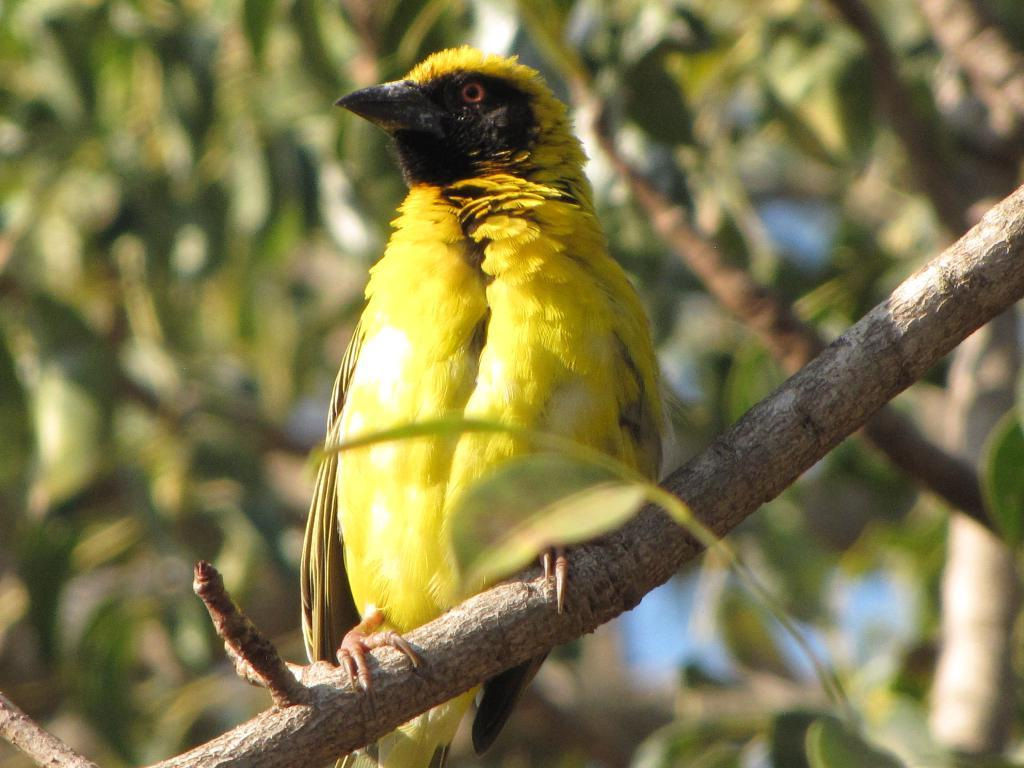What type of animal can be seen in the image? There is a bird in the image. Where is the bird located? The bird is on the branch of a tree. What can be seen in the background of the image? There is greenery and the sky visible in the background of the image. What type of poison is the bird using to punish the rain in the image? There is no mention of poison, punishment, or rain in the image. The image features a bird on a tree branch with greenery and the sky in the background. 